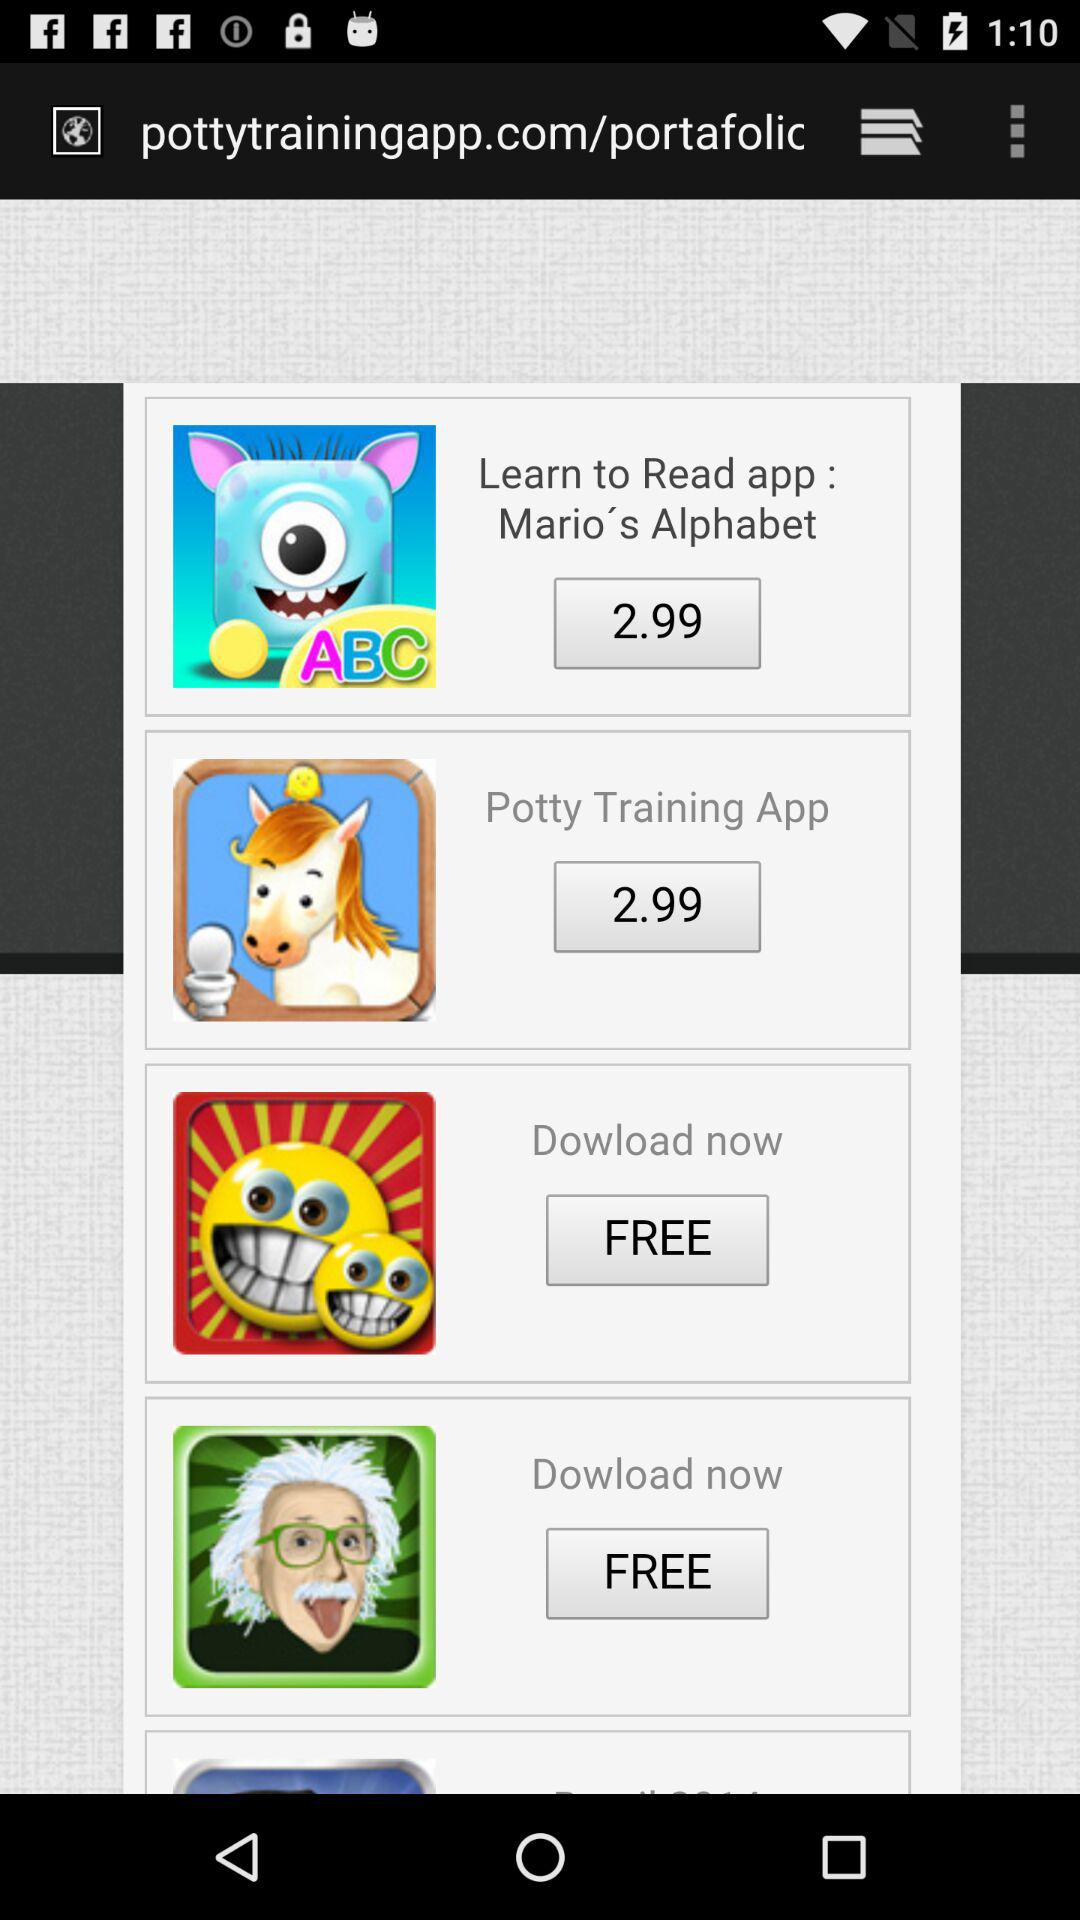How much is the price of the "Potty Training App"? The price of the "Potty Training App" is 2.99. 